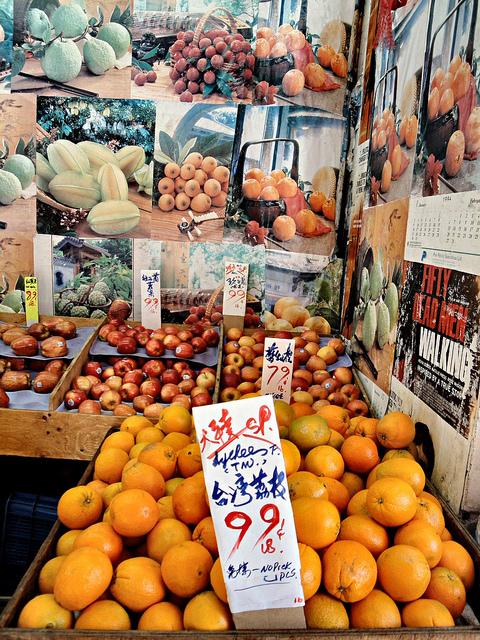What type of food is featured in photographs?
Short answer required. Fruit. How much do the oranges cost?
Answer briefly. 99 cents per pound. What fruit is that?
Be succinct. Orange. Does the fruits seem to be fresh?
Answer briefly. Yes. 